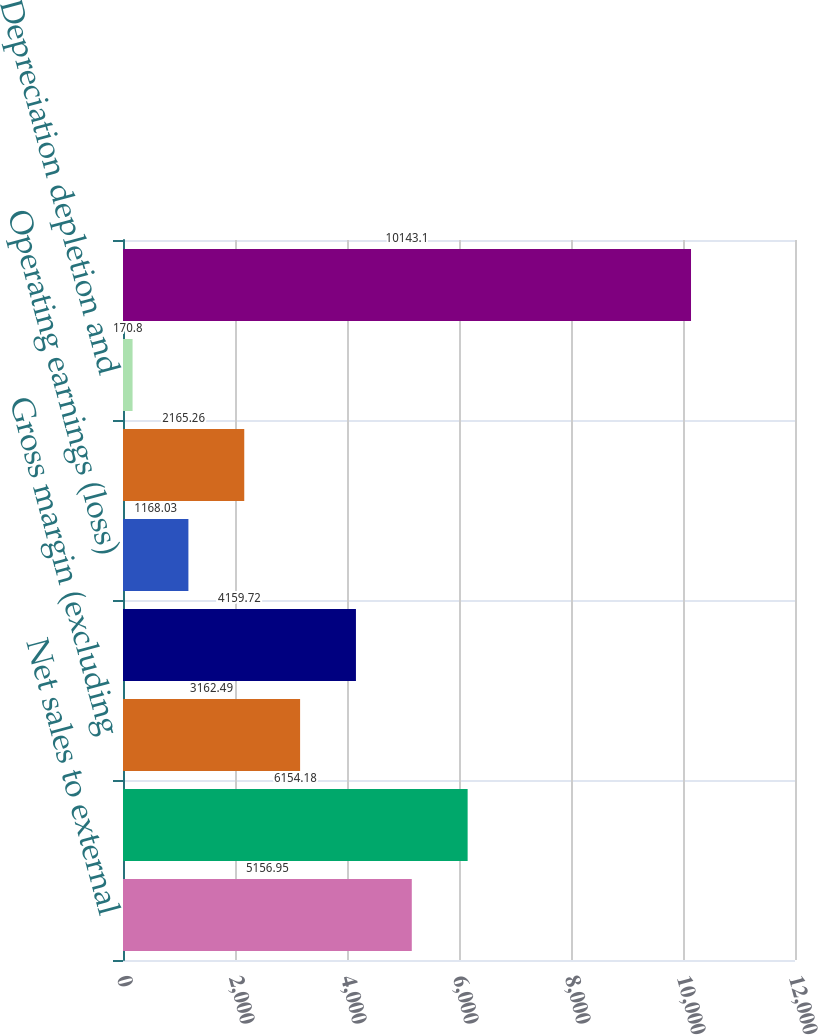<chart> <loc_0><loc_0><loc_500><loc_500><bar_chart><fcel>Net sales to external<fcel>Net sales<fcel>Gross margin (excluding<fcel>Gross margin^(a)<fcel>Operating earnings (loss)<fcel>Capital expenditures<fcel>Depreciation depletion and<fcel>Total assets as of December 31<nl><fcel>5156.95<fcel>6154.18<fcel>3162.49<fcel>4159.72<fcel>1168.03<fcel>2165.26<fcel>170.8<fcel>10143.1<nl></chart> 